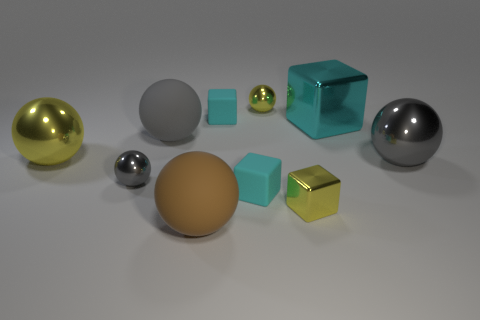There is a big matte sphere behind the small yellow metal block; what number of things are in front of it?
Offer a terse response. 6. Is the gray matte ball the same size as the brown matte sphere?
Your response must be concise. Yes. How many other large spheres have the same material as the brown sphere?
Offer a terse response. 1. What size is the other rubber thing that is the same shape as the brown object?
Keep it short and to the point. Large. Do the tiny metal thing behind the large cyan shiny block and the small gray object have the same shape?
Your response must be concise. Yes. What is the shape of the yellow object on the right side of the yellow metal sphere that is right of the small gray metallic object?
Your answer should be compact. Cube. Is there anything else that has the same shape as the tiny gray metallic thing?
Make the answer very short. Yes. What color is the other rubber thing that is the same shape as the big brown matte object?
Provide a short and direct response. Gray. Do the large metallic cube and the small rubber object behind the big yellow ball have the same color?
Your response must be concise. Yes. What is the shape of the thing that is on the left side of the small yellow sphere and behind the cyan metal cube?
Your answer should be very brief. Cube. 